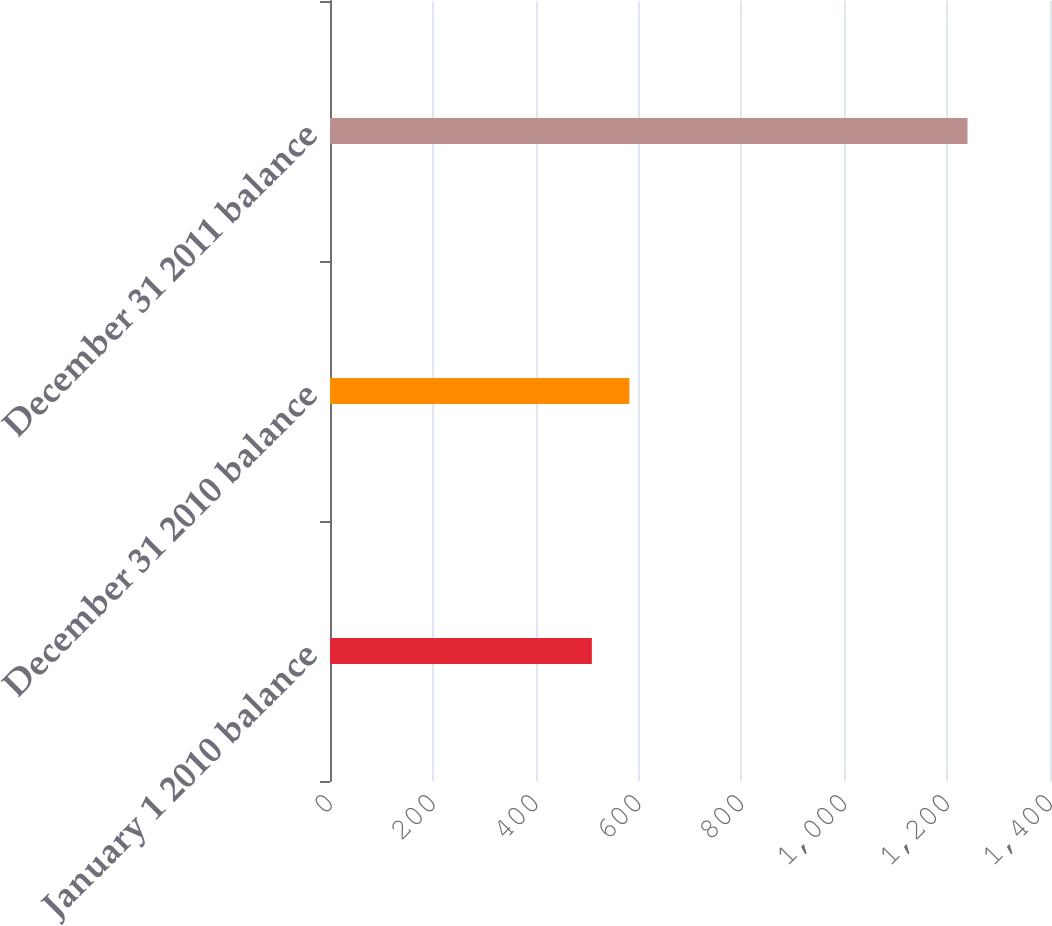Convert chart. <chart><loc_0><loc_0><loc_500><loc_500><bar_chart><fcel>January 1 2010 balance<fcel>December 31 2010 balance<fcel>December 31 2011 balance<nl><fcel>509.2<fcel>582.24<fcel>1239.6<nl></chart> 